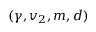<formula> <loc_0><loc_0><loc_500><loc_500>( \gamma , v _ { 2 } , m , d )</formula> 